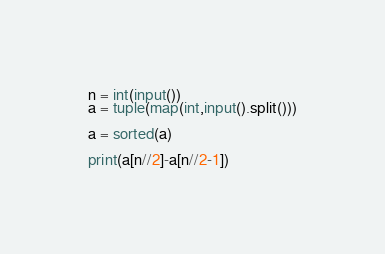Convert code to text. <code><loc_0><loc_0><loc_500><loc_500><_Python_>n = int(input())
a = tuple(map(int,input().split()))

a = sorted(a)

print(a[n//2]-a[n//2-1])
</code> 